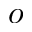Convert formula to latex. <formula><loc_0><loc_0><loc_500><loc_500>o</formula> 